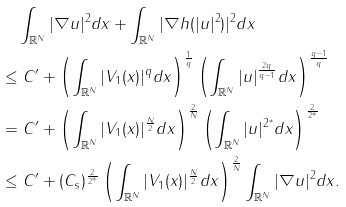<formula> <loc_0><loc_0><loc_500><loc_500>& \quad \int _ { \mathbb { R } ^ { N } } | \nabla u | ^ { 2 } d x + \int _ { \mathbb { R } ^ { N } } | \nabla h ( | u | ^ { 2 } ) | ^ { 2 } d x \\ & \leq C ^ { \prime } + \left ( \int _ { \mathbb { R } ^ { N } } | V _ { 1 } ( x ) | ^ { q } d x \right ) ^ { \frac { 1 } { q } } \left ( \int _ { \mathbb { R } ^ { N } } | u | ^ { \frac { 2 q } { q - 1 } } d x \right ) ^ { \frac { q - 1 } { q } } \\ & = C ^ { \prime } + \left ( \int _ { \mathbb { R } ^ { N } } | V _ { 1 } ( x ) | ^ { \frac { N } { 2 } } d x \right ) ^ { \frac { 2 } { N } } \left ( \int _ { \mathbb { R } ^ { N } } | u | ^ { 2 ^ { * } } d x \right ) ^ { \frac { 2 } { 2 ^ { * } } } \\ & \leq C ^ { \prime } + ( C _ { s } ) ^ { \frac { 2 } { 2 ^ { * } } } \left ( \int _ { \mathbb { R } ^ { N } } | V _ { 1 } ( x ) | ^ { \frac { N } { 2 } } d x \right ) ^ { \frac { 2 } { N } } \int _ { \mathbb { R } ^ { N } } | \nabla u | ^ { 2 } d x .</formula> 